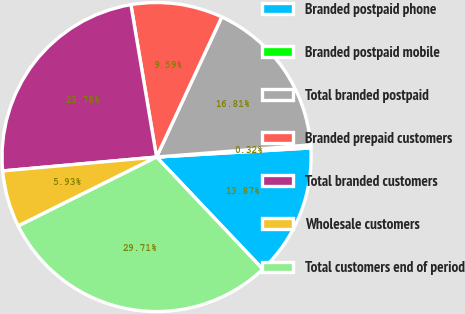Convert chart to OTSL. <chart><loc_0><loc_0><loc_500><loc_500><pie_chart><fcel>Branded postpaid phone<fcel>Branded postpaid mobile<fcel>Total branded postpaid<fcel>Branded prepaid customers<fcel>Total branded customers<fcel>Wholesale customers<fcel>Total customers end of period<nl><fcel>13.87%<fcel>0.32%<fcel>16.81%<fcel>9.59%<fcel>23.78%<fcel>5.93%<fcel>29.71%<nl></chart> 